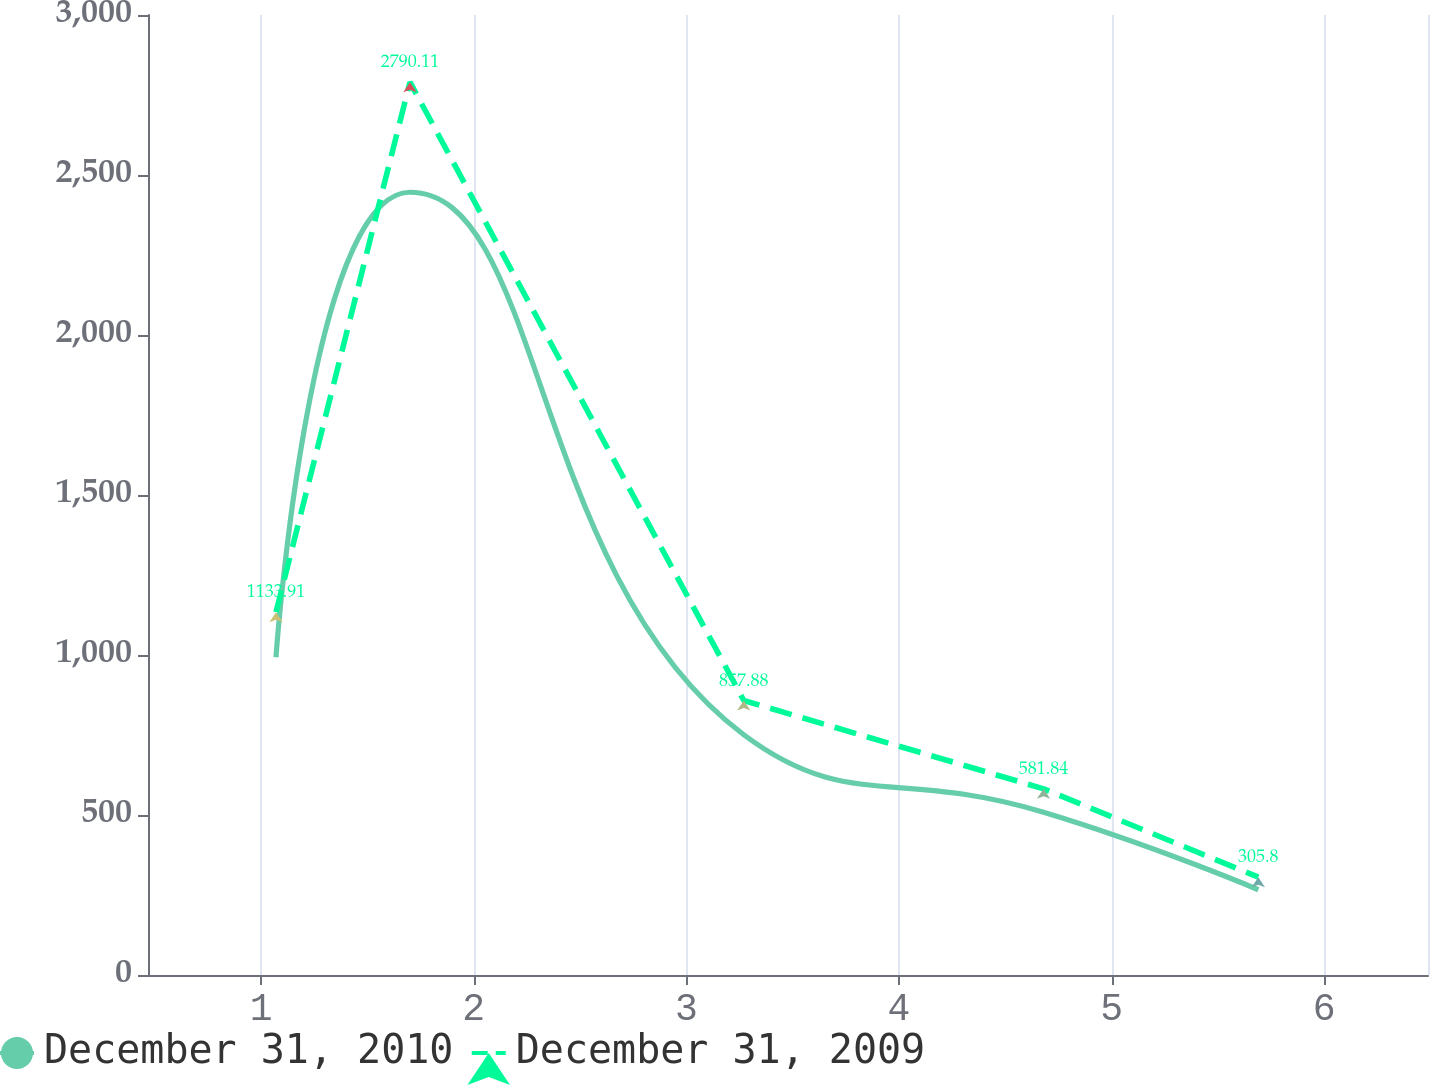Convert chart to OTSL. <chart><loc_0><loc_0><loc_500><loc_500><line_chart><ecel><fcel>December 31, 2010<fcel>December 31, 2009<nl><fcel>1.07<fcel>992.99<fcel>1133.91<nl><fcel>1.7<fcel>2446.1<fcel>2790.11<nl><fcel>3.27<fcel>750.81<fcel>857.88<nl><fcel>4.68<fcel>508.62<fcel>581.84<nl><fcel>5.69<fcel>266.44<fcel>305.8<nl><fcel>7.09<fcel>24.25<fcel>29.76<nl></chart> 